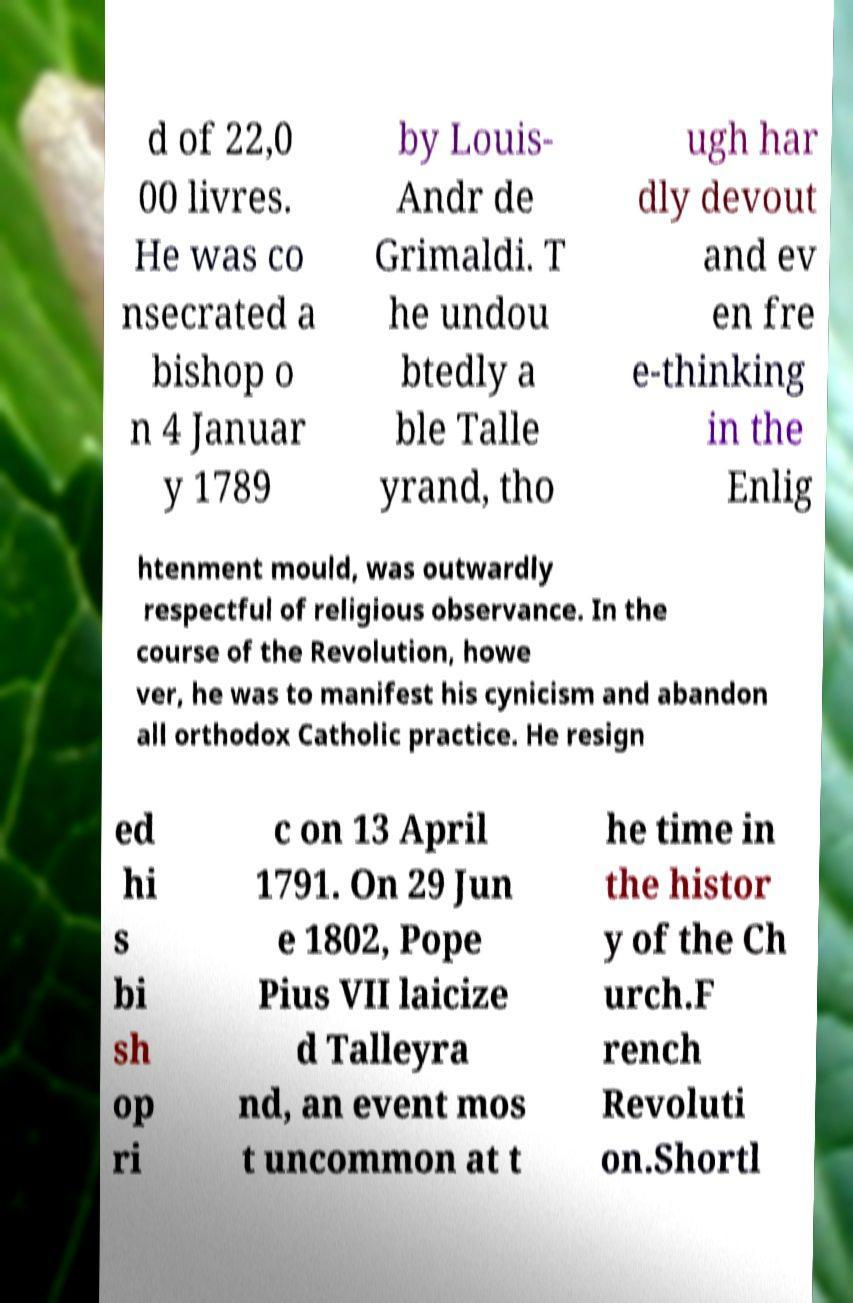Could you extract and type out the text from this image? d of 22,0 00 livres. He was co nsecrated a bishop o n 4 Januar y 1789 by Louis- Andr de Grimaldi. T he undou btedly a ble Talle yrand, tho ugh har dly devout and ev en fre e-thinking in the Enlig htenment mould, was outwardly respectful of religious observance. In the course of the Revolution, howe ver, he was to manifest his cynicism and abandon all orthodox Catholic practice. He resign ed hi s bi sh op ri c on 13 April 1791. On 29 Jun e 1802, Pope Pius VII laicize d Talleyra nd, an event mos t uncommon at t he time in the histor y of the Ch urch.F rench Revoluti on.Shortl 